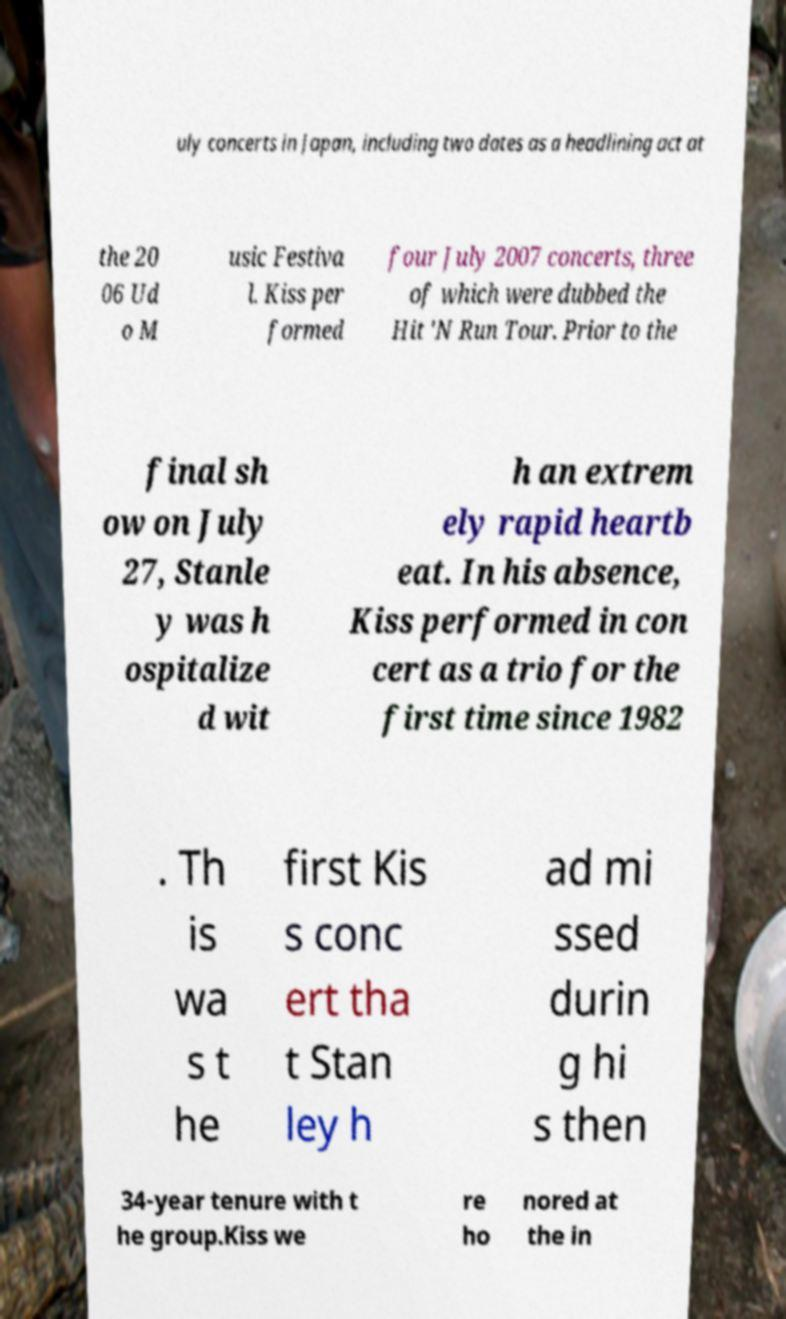What messages or text are displayed in this image? I need them in a readable, typed format. uly concerts in Japan, including two dates as a headlining act at the 20 06 Ud o M usic Festiva l. Kiss per formed four July 2007 concerts, three of which were dubbed the Hit 'N Run Tour. Prior to the final sh ow on July 27, Stanle y was h ospitalize d wit h an extrem ely rapid heartb eat. In his absence, Kiss performed in con cert as a trio for the first time since 1982 . Th is wa s t he first Kis s conc ert tha t Stan ley h ad mi ssed durin g hi s then 34-year tenure with t he group.Kiss we re ho nored at the in 